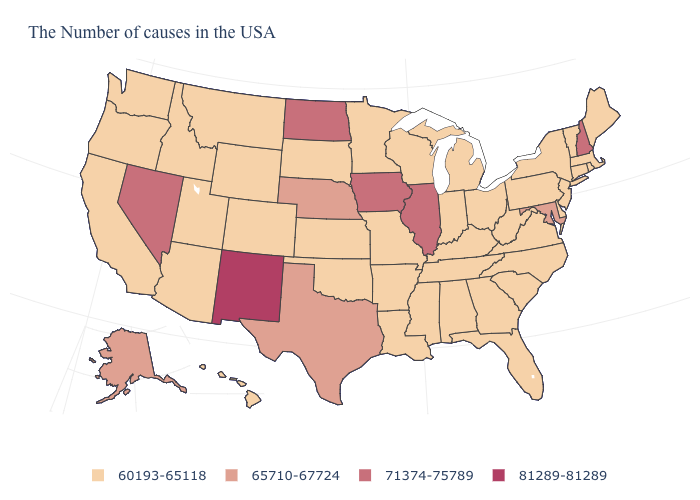Is the legend a continuous bar?
Concise answer only. No. Among the states that border Rhode Island , which have the highest value?
Keep it brief. Massachusetts, Connecticut. What is the highest value in the USA?
Short answer required. 81289-81289. Name the states that have a value in the range 65710-67724?
Short answer required. Maryland, Nebraska, Texas, Alaska. What is the highest value in states that border Delaware?
Short answer required. 65710-67724. Does New Mexico have the highest value in the West?
Quick response, please. Yes. Which states have the lowest value in the MidWest?
Short answer required. Ohio, Michigan, Indiana, Wisconsin, Missouri, Minnesota, Kansas, South Dakota. What is the lowest value in the USA?
Keep it brief. 60193-65118. Which states hav the highest value in the MidWest?
Quick response, please. Illinois, Iowa, North Dakota. Does Maryland have the lowest value in the USA?
Short answer required. No. Name the states that have a value in the range 81289-81289?
Keep it brief. New Mexico. Is the legend a continuous bar?
Short answer required. No. What is the lowest value in the USA?
Short answer required. 60193-65118. Is the legend a continuous bar?
Be succinct. No. What is the value of Florida?
Give a very brief answer. 60193-65118. 